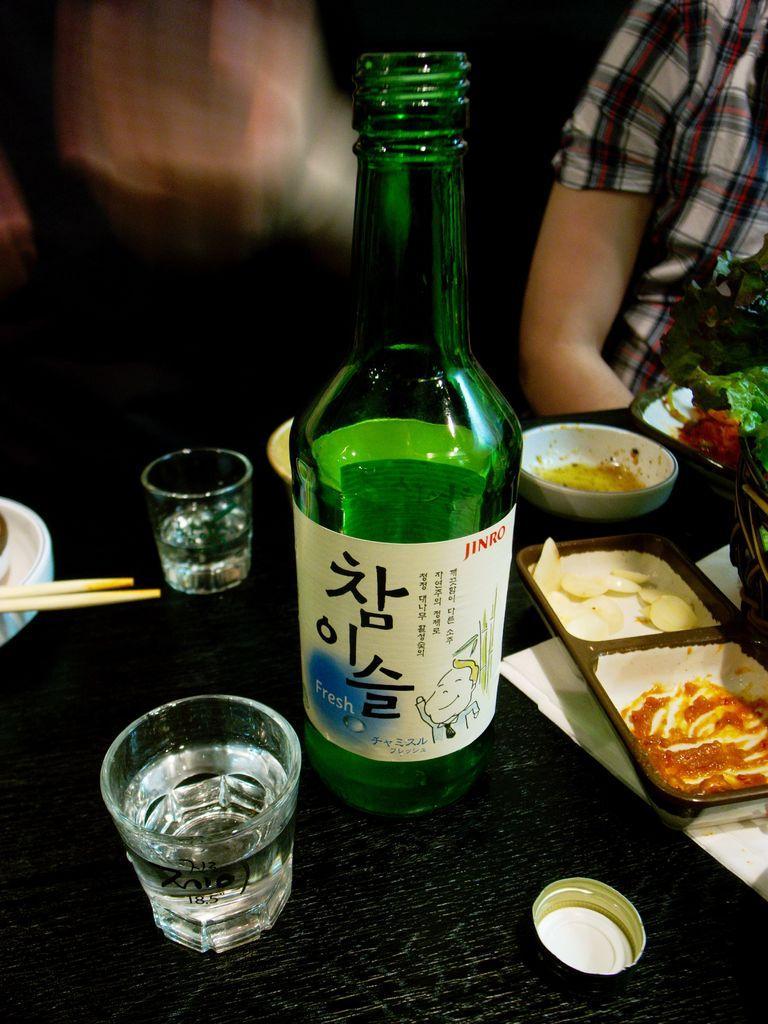Can you describe this image briefly? In the image we can see there is a wine bottle which is in green colour and beside it there are two wine glasses which are filled with wine and there is a cap over here. Beside it there is a plate which is divided in two section in one is sauce and in another thing there is a chips. Beside it there is a bowl and in front of the table there is a person who is sitting. 